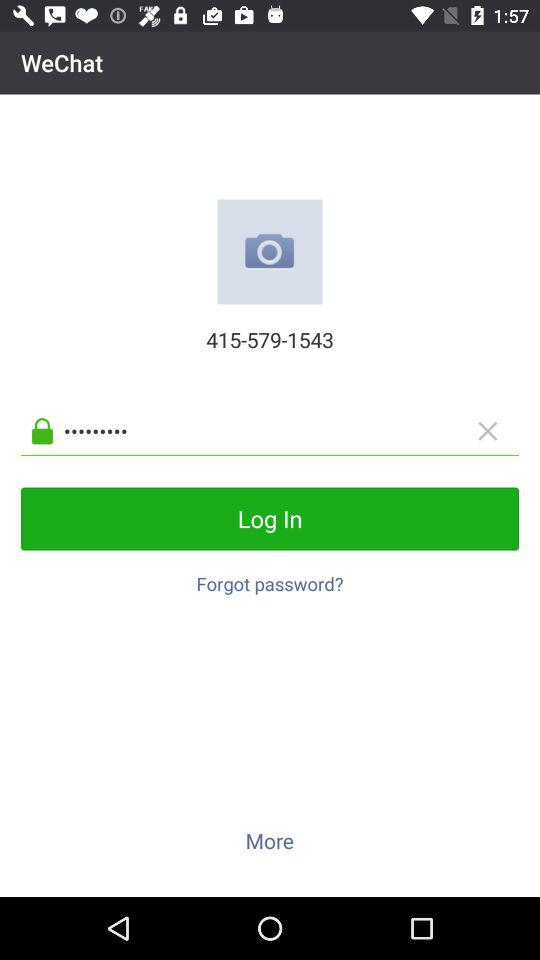What is the name of the application? The name of the application is "WeChat". 